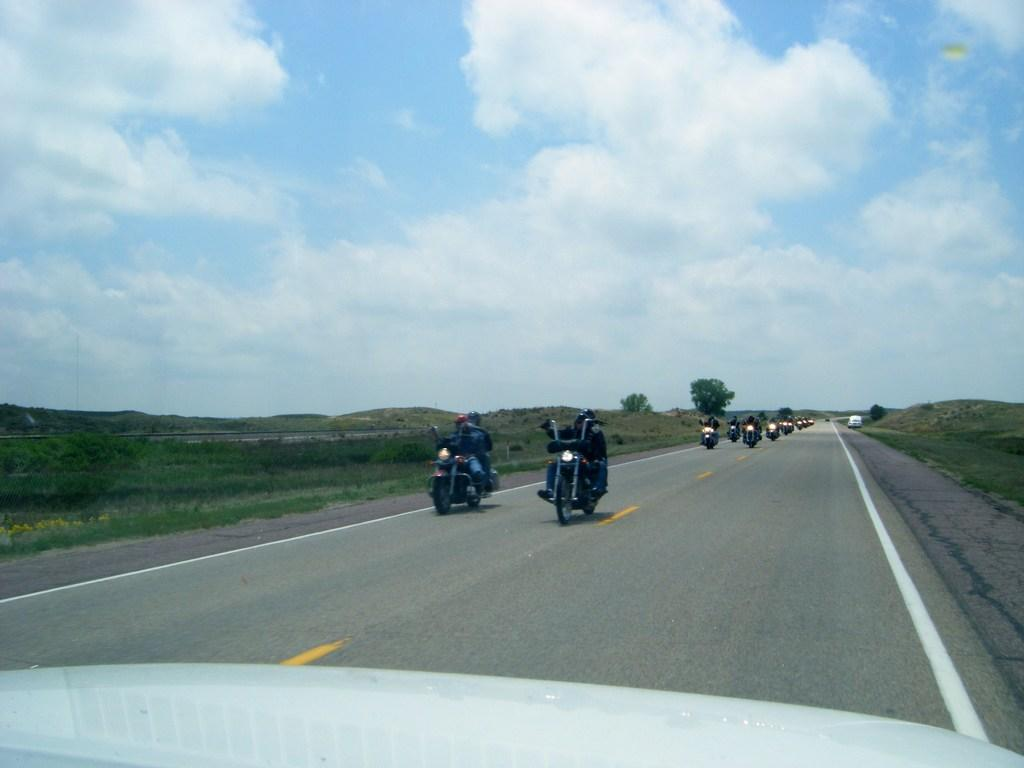What is the color of the surface at the bottom of the image? The surface at the bottom of the image is white. What activity can be seen taking place in the background of the image? People are riding bikes in the background of the image. What type of vegetation is present on either side of the image? There is greenery on either side of the image. What is visible at the top of the image? The sky is visible at the top of the image. Can you describe the sky in the image? The sky in the image has at least one cloud visible. What type of button can be seen on the white surface in the image? There is no button present on the white surface in the image. How does the pain affect the people riding bikes in the image? There is no mention of pain in the image; people are simply riding bikes. 